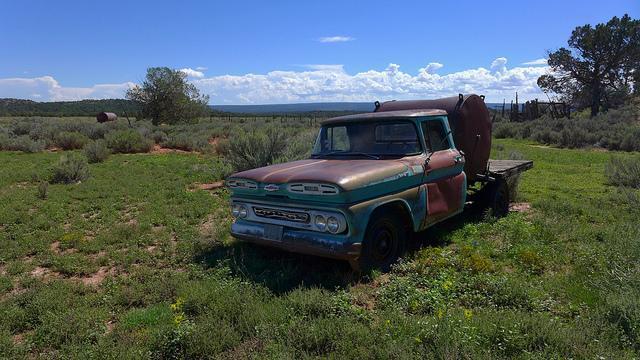How many vehicles is there?
Give a very brief answer. 1. How many women are wearing blue scarfs?
Give a very brief answer. 0. 